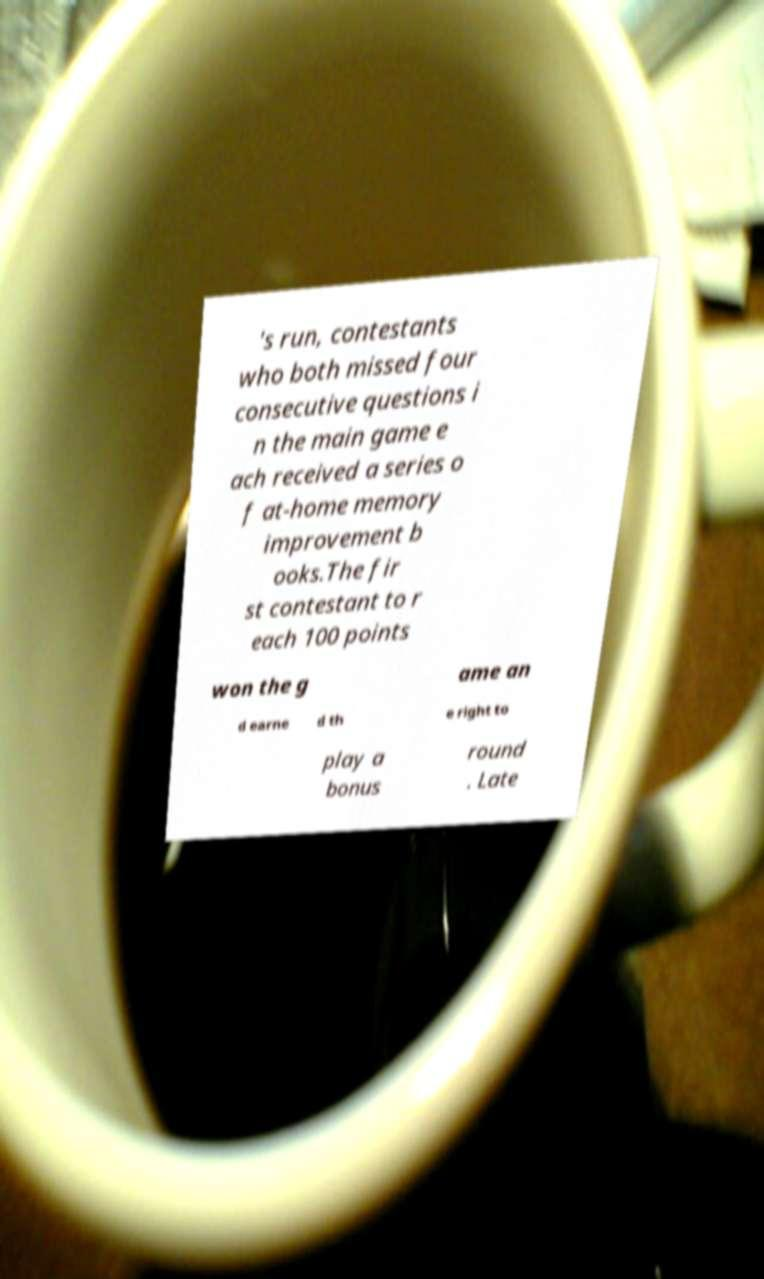Please identify and transcribe the text found in this image. 's run, contestants who both missed four consecutive questions i n the main game e ach received a series o f at-home memory improvement b ooks.The fir st contestant to r each 100 points won the g ame an d earne d th e right to play a bonus round . Late 